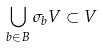<formula> <loc_0><loc_0><loc_500><loc_500>\bigcup _ { b \in B } \sigma _ { b } V \subset V</formula> 